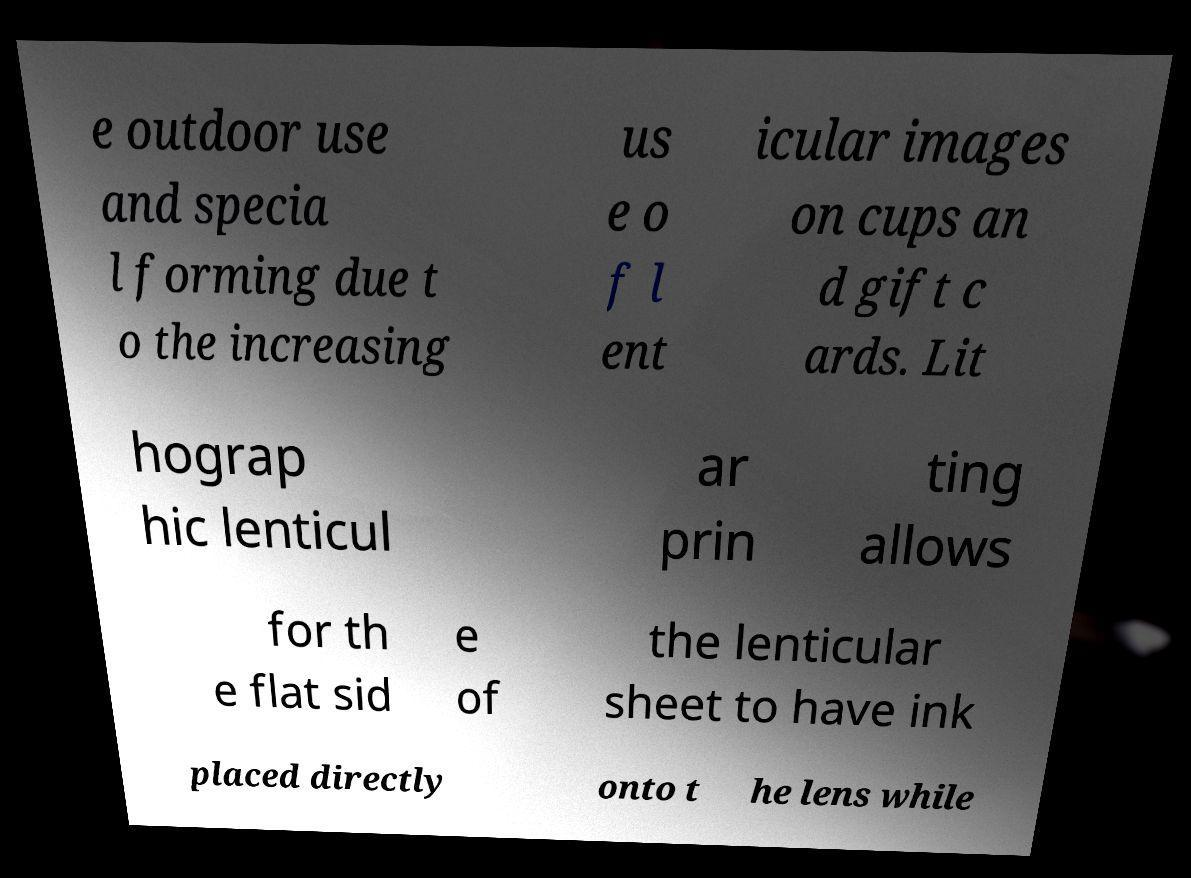For documentation purposes, I need the text within this image transcribed. Could you provide that? e outdoor use and specia l forming due t o the increasing us e o f l ent icular images on cups an d gift c ards. Lit hograp hic lenticul ar prin ting allows for th e flat sid e of the lenticular sheet to have ink placed directly onto t he lens while 